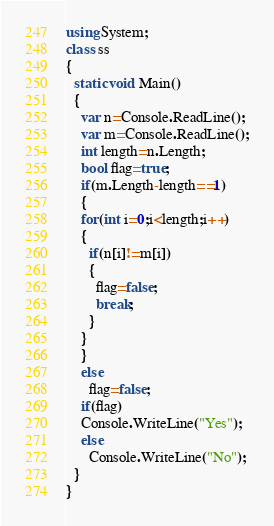Convert code to text. <code><loc_0><loc_0><loc_500><loc_500><_C#_>using System;
class ss
{
  static void Main()
  {
    var n=Console.ReadLine();
    var m=Console.ReadLine();
    int length=n.Length;
    bool flag=true;
    if(m.Length-length==1)
    {
    for(int i=0;i<length;i++)
    {
      if(n[i]!=m[i])
      {
        flag=false;
        break;
      }
    }
    }
    else
      flag=false;
    if(flag)
    Console.WriteLine("Yes");
    else
      Console.WriteLine("No");
  }
}</code> 